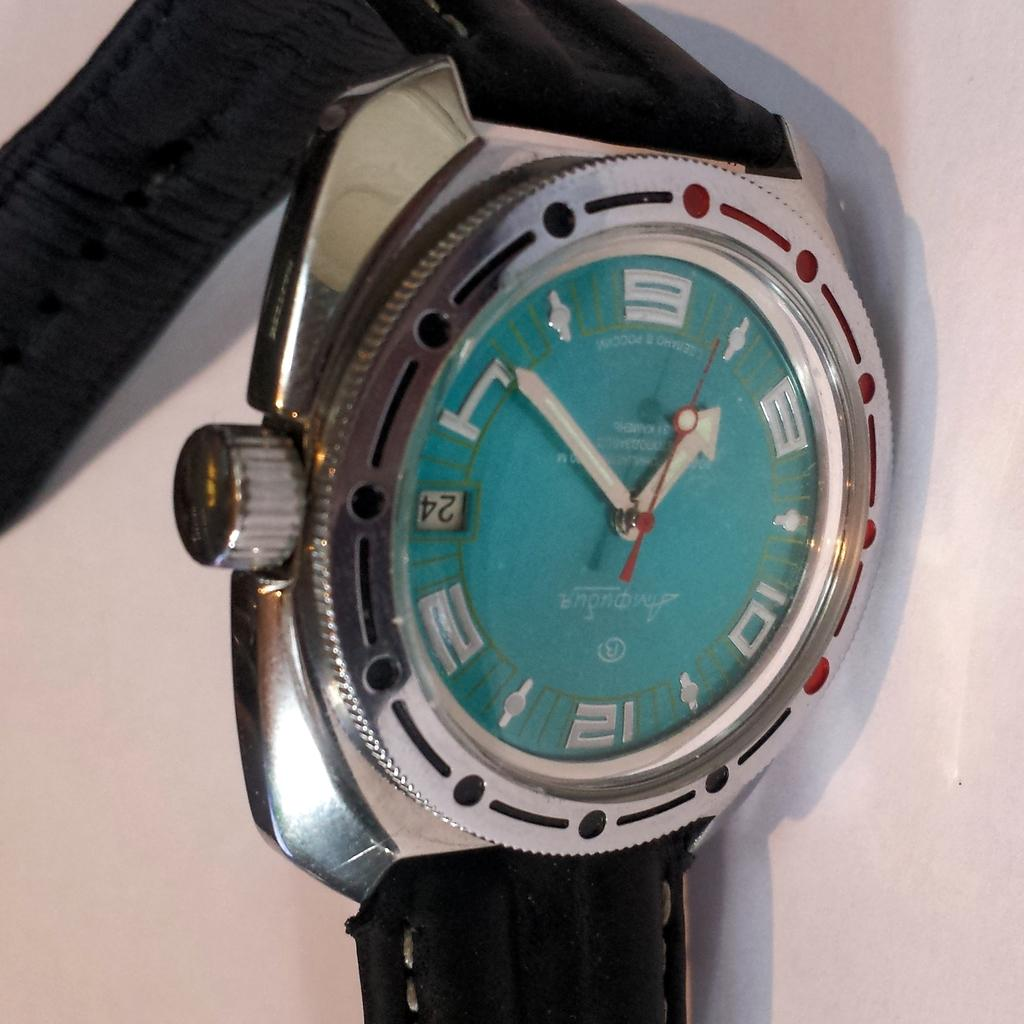<image>
Offer a succinct explanation of the picture presented. a metal and green watch shows the time is 1:50 